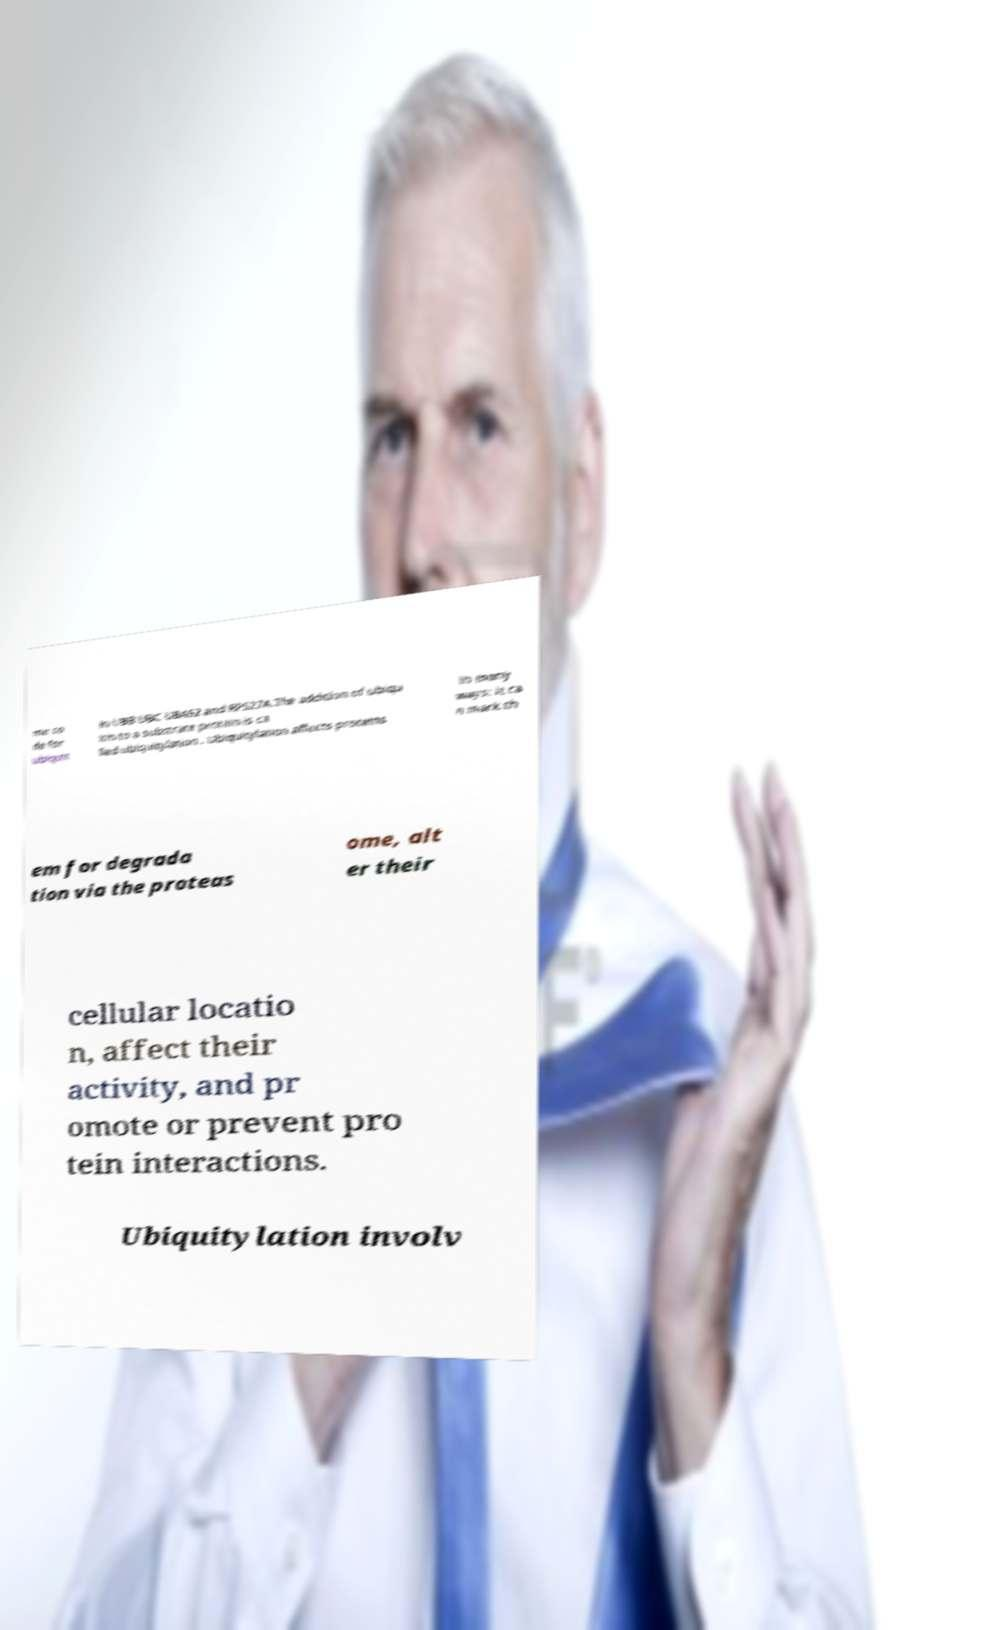For documentation purposes, I need the text within this image transcribed. Could you provide that? me co de for ubiquit in UBB UBC UBA52 and RPS27A.The addition of ubiqu itin to a substrate protein is ca lled ubiquitylation . Ubiquitylation affects proteins in many ways: it ca n mark th em for degrada tion via the proteas ome, alt er their cellular locatio n, affect their activity, and pr omote or prevent pro tein interactions. Ubiquitylation involv 